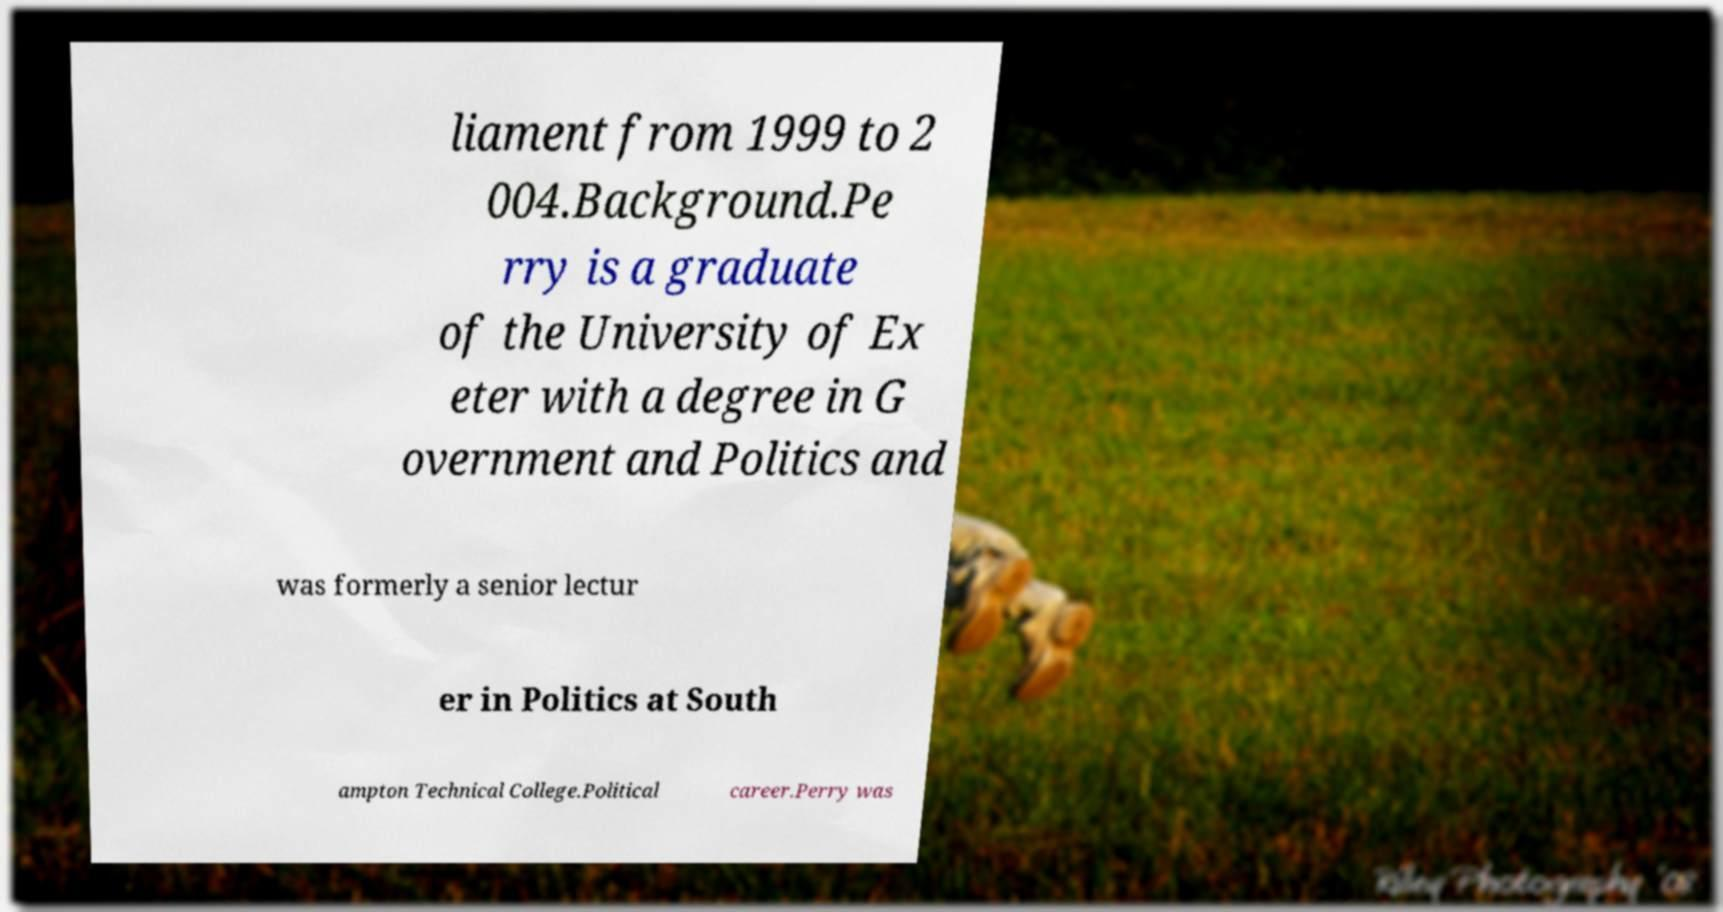There's text embedded in this image that I need extracted. Can you transcribe it verbatim? liament from 1999 to 2 004.Background.Pe rry is a graduate of the University of Ex eter with a degree in G overnment and Politics and was formerly a senior lectur er in Politics at South ampton Technical College.Political career.Perry was 